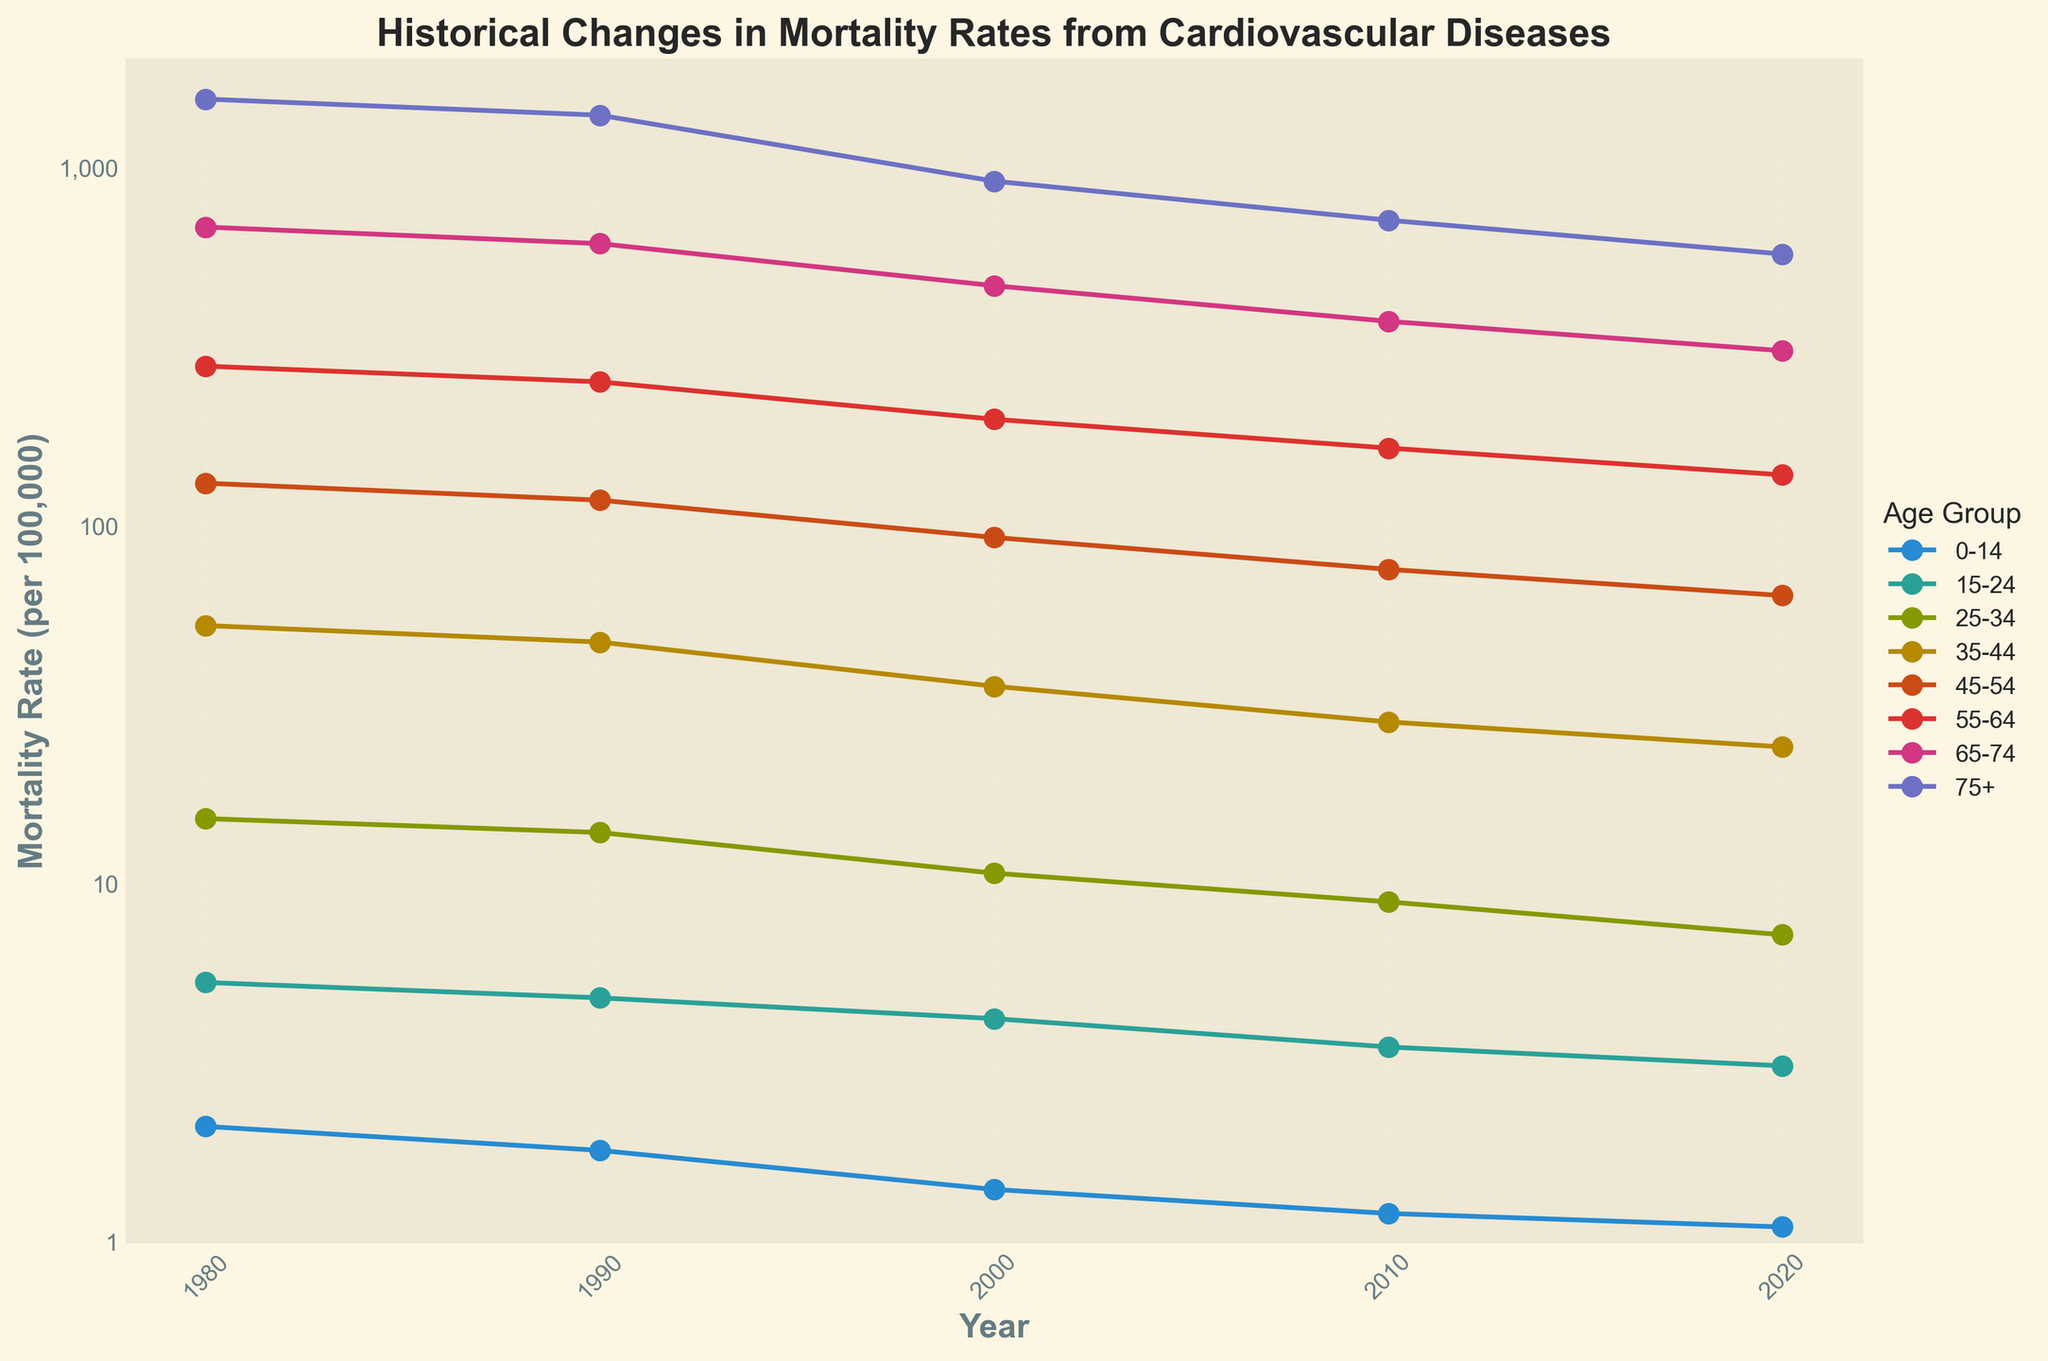What is the title of the plot? The title is displayed at the top center of the plot. It provides a brief description of what the plot is about.
Answer: Historical Changes in Mortality Rates from Cardiovascular Diseases What is the mortality rate for the age group 35-44 in the year 2010? Locate the line representing the age group 35-44 and follow it to the point corresponding to the year 2010. The y-value of this point represents the mortality rate for that age group in that year.
Answer: 28.3 Which age group showed the highest mortality rate in the year 2000? Identify the points corresponding to the year 2000 for each age group line. The age group with the highest y-value (mortality rate) at this year is the answer.
Answer: 75+ By how much did the mortality rate for the age group 55-64 decrease from 1980 to 2020? From the plot, locate the points for the age group 55-64 in the years 1980 and 2020. Subtract the 2020 value from the 1980 value to find the decrease.
Answer: 278.9 - 138.6 = 140.3 Which age group had the smallest change in mortality rate between 1980 and 2020? Observing all age groups, compare the difference in mortality rate from 1980 to 2020 for each group. The group with the smallest difference is the answer.
Answer: 0-14 What trend in the mortality rates for the 45-54 age group can be observed over the years? Follow the line for the 45-54 age group across the years and note the general direction and changes in the plot.
Answer: A decreasing trend Which age group’s mortality rate improved the most between 1980 and 2000? Look at the points for 1980 and 2000 for each age group, calculate the rate of improvement (difference between 1980 and 2000 values), and identify the group with the largest improvement.
Answer: 75+ In what year did the 25-34 age group see their mortality rate drop below 10 per 100,000? Follow the line for the 25-34 age group and identify the first point where the y-value falls below 10.
Answer: 2000 How does the mortality rate for the 65-74 age group in 2020 compare to that in 1980? Compare the y-values of the points corresponding to the 65-74 age group in the years 1980 and 2020 to see the difference.
Answer: 1980: 682.1, 2020: 307.9. The rate in 2020 is lower What is unique about how the y-axis is scaled in this plot? Look at the y-axis labels and the way tick marks are represented to identify the scaling method used.
Answer: It uses a logarithmic scale 